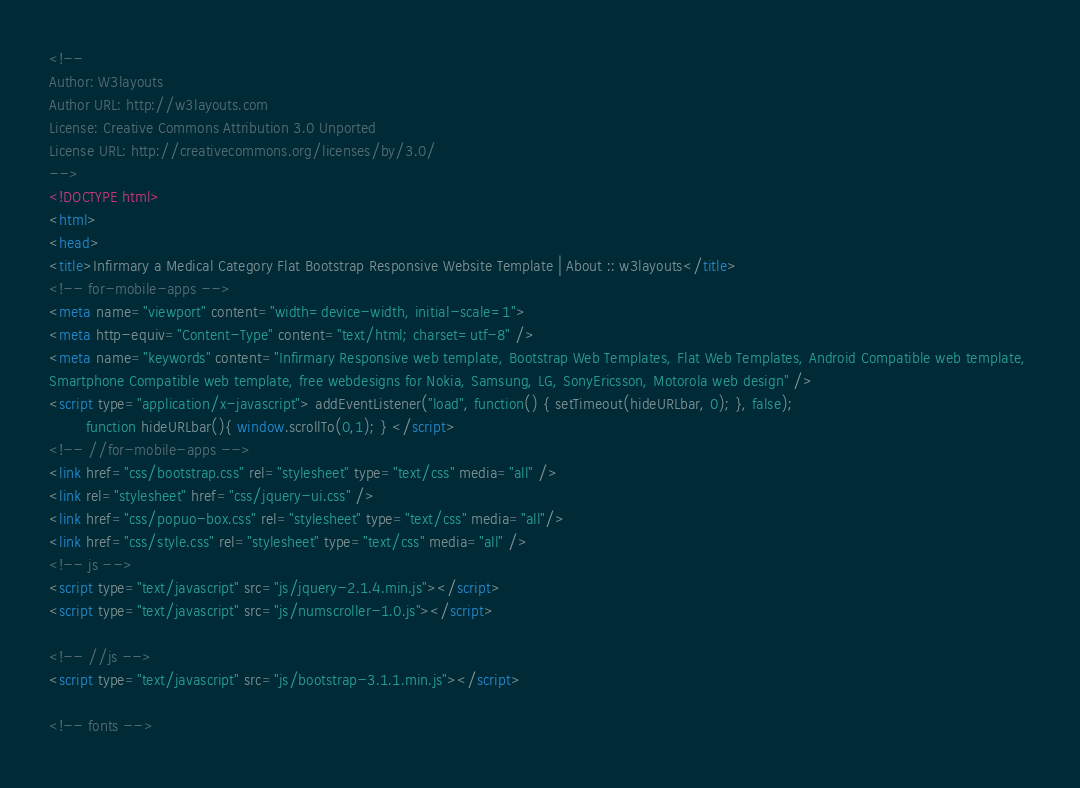<code> <loc_0><loc_0><loc_500><loc_500><_HTML_>
<!--
Author: W3layouts
Author URL: http://w3layouts.com
License: Creative Commons Attribution 3.0 Unported
License URL: http://creativecommons.org/licenses/by/3.0/
-->
<!DOCTYPE html>
<html>
<head>
<title>Infirmary a Medical Category Flat Bootstrap Responsive Website Template | About :: w3layouts</title>
<!-- for-mobile-apps -->
<meta name="viewport" content="width=device-width, initial-scale=1">
<meta http-equiv="Content-Type" content="text/html; charset=utf-8" />
<meta name="keywords" content="Infirmary Responsive web template, Bootstrap Web Templates, Flat Web Templates, Android Compatible web template, 
Smartphone Compatible web template, free webdesigns for Nokia, Samsung, LG, SonyEricsson, Motorola web design" />
<script type="application/x-javascript"> addEventListener("load", function() { setTimeout(hideURLbar, 0); }, false);
		function hideURLbar(){ window.scrollTo(0,1); } </script>
<!-- //for-mobile-apps -->
<link href="css/bootstrap.css" rel="stylesheet" type="text/css" media="all" />
<link rel="stylesheet" href="css/jquery-ui.css" />
<link href="css/popuo-box.css" rel="stylesheet" type="text/css" media="all"/>
<link href="css/style.css" rel="stylesheet" type="text/css" media="all" />
<!-- js -->
<script type="text/javascript" src="js/jquery-2.1.4.min.js"></script>
<script type="text/javascript" src="js/numscroller-1.0.js"></script>

<!-- //js -->
<script type="text/javascript" src="js/bootstrap-3.1.1.min.js"></script>

<!-- fonts --></code> 